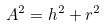Convert formula to latex. <formula><loc_0><loc_0><loc_500><loc_500>A ^ { 2 } = h ^ { 2 } + r ^ { 2 }</formula> 